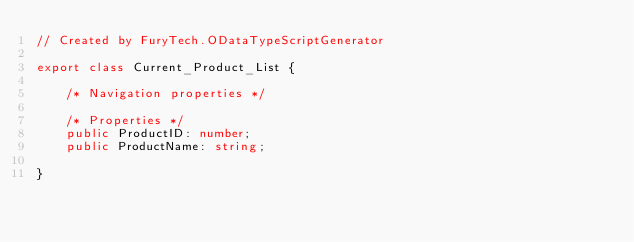Convert code to text. <code><loc_0><loc_0><loc_500><loc_500><_TypeScript_>// Created by FuryTech.ODataTypeScriptGenerator

export class Current_Product_List {

    /* Navigation properties */

    /* Properties */
    public ProductID: number;
    public ProductName: string;

}</code> 